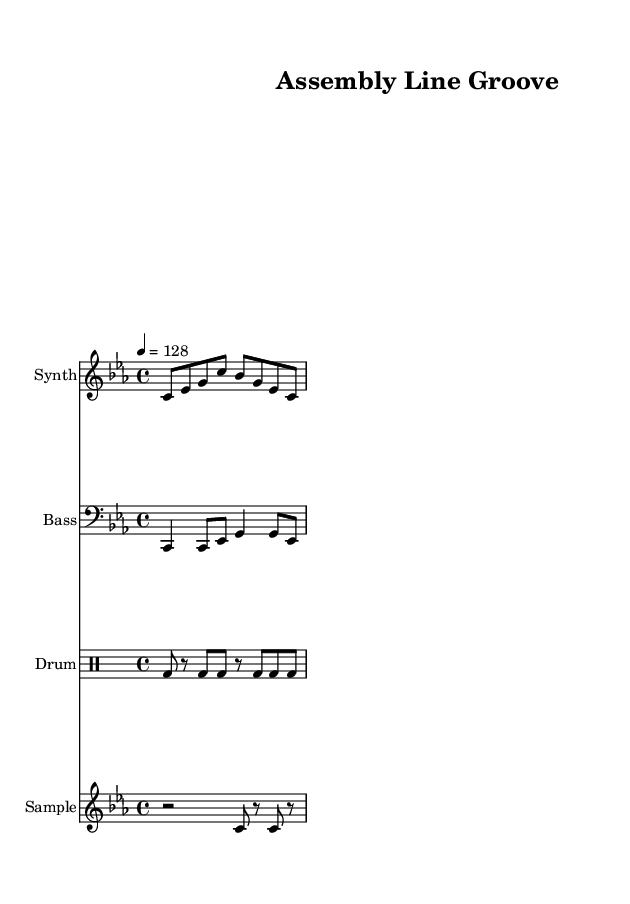What is the key signature of this music? The key signature is indicated at the beginning of the score, showing C minor, which has three flats (B♭, E♭, and A♭).
Answer: C minor What is the time signature of this music? The time signature is found in the measure at the beginning, which indicates that there are four beats in each measure. This is denoted by the notation 4/4.
Answer: 4/4 What is the tempo marking of this music? The tempo marking shows that the piece should be played at a speed of 128 beats per minute, indicated as "4 = 128" above the staff.
Answer: 128 Which instrument plays the bass line? The bass line is written in the staff labeled "Bass", which uses the bass clef and plays lower pitches, distinct from the synthesizer and other parts.
Answer: Bass How many measures are there in the drum pattern? The drum pattern is displayed within a single series of beats, and upon reviewing the notation, it shows four measures in total due to the repeating structure.
Answer: Four What type of rhythm pattern is used in the synthesizer part? The synthesizer part follows a rhythmic motif of eighth notes and quarter notes with accents on the first beat, reflecting an industrial groove.
Answer: Eighth and quarter notes Which rhythmic element emphasizes the factory machinery influence? The drum machine part employs a strong kick drum pattern that mimics mechanical repetitive sounds, typical in industrial dance music.
Answer: Kick drum pattern 